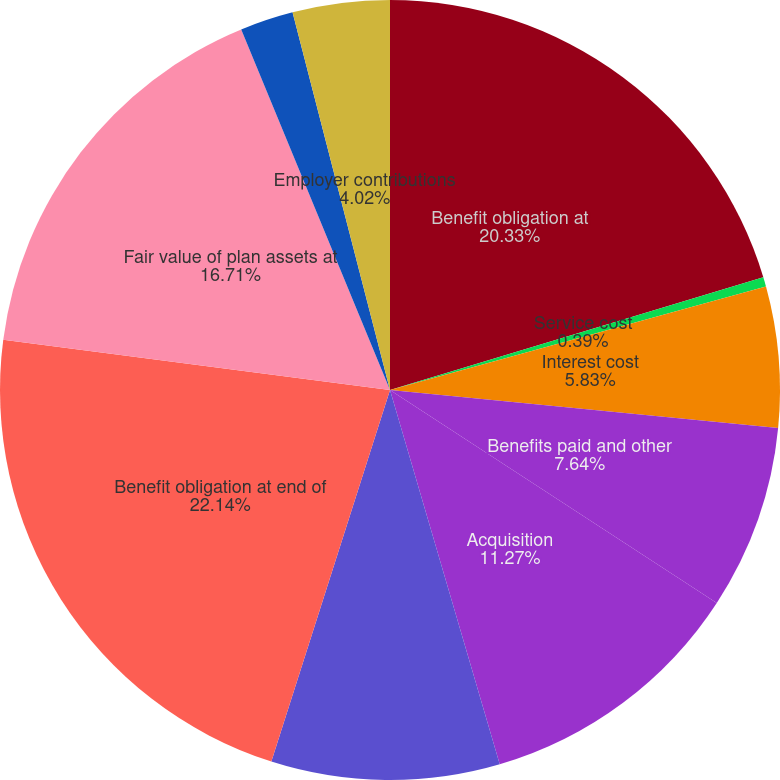<chart> <loc_0><loc_0><loc_500><loc_500><pie_chart><fcel>Benefit obligation at<fcel>Service cost<fcel>Interest cost<fcel>Benefits paid and other<fcel>Acquisition<fcel>Actuarial loss (gain)<fcel>Benefit obligation at end of<fcel>Fair value of plan assets at<fcel>Actual return on plan assets<fcel>Employer contributions<nl><fcel>20.33%<fcel>0.39%<fcel>5.83%<fcel>7.64%<fcel>11.27%<fcel>9.46%<fcel>22.14%<fcel>16.71%<fcel>2.21%<fcel>4.02%<nl></chart> 